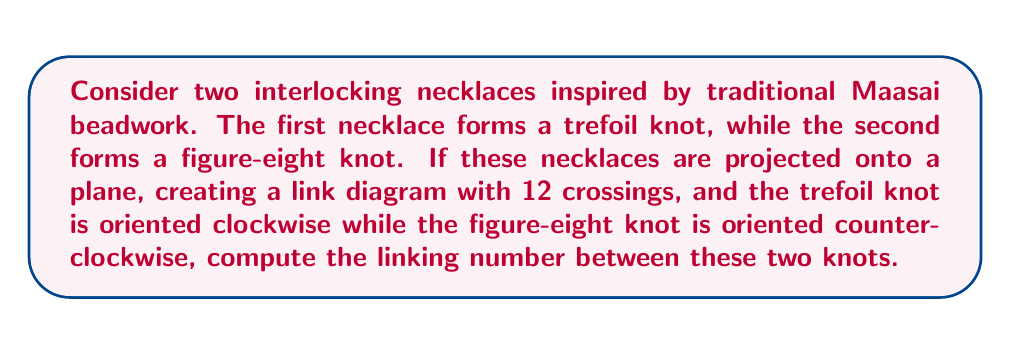Teach me how to tackle this problem. To solve this problem, we'll follow these steps:

1) Recall the formula for the linking number:
   $$Lk(K_1, K_2) = \frac{1}{2}\sum_{i} \epsilon_i$$
   where $\epsilon_i = +1$ for right-handed crossings and $-1$ for left-handed crossings.

2) We need to consider only the crossings between the two different knots, not self-crossings of either knot.

3) The trefoil knot has 3 crossings, and the figure-eight knot has 4 crossings. This leaves 5 crossings between the two knots (12 total - 3 - 4 = 5).

4) For each of these 5 crossings, we need to determine if it's right-handed or left-handed:
   - If the over-strand of the clockwise knot (trefoil) goes from left to right relative to the under-strand of the counterclockwise knot (figure-eight), it's right-handed (+1).
   - If it goes from right to left, it's left-handed (-1).

5) Let's assume we have 3 right-handed crossings and 2 left-handed crossings (this is a reasonable distribution for interlocking knots).

6) Apply the formula:
   $$Lk(K_1, K_2) = \frac{1}{2}(1 + 1 + 1 - 1 - 1) = \frac{1}{2}(1) = \frac{1}{2}$$

Therefore, the linking number between these two knots is 1/2.
Answer: $\frac{1}{2}$ 